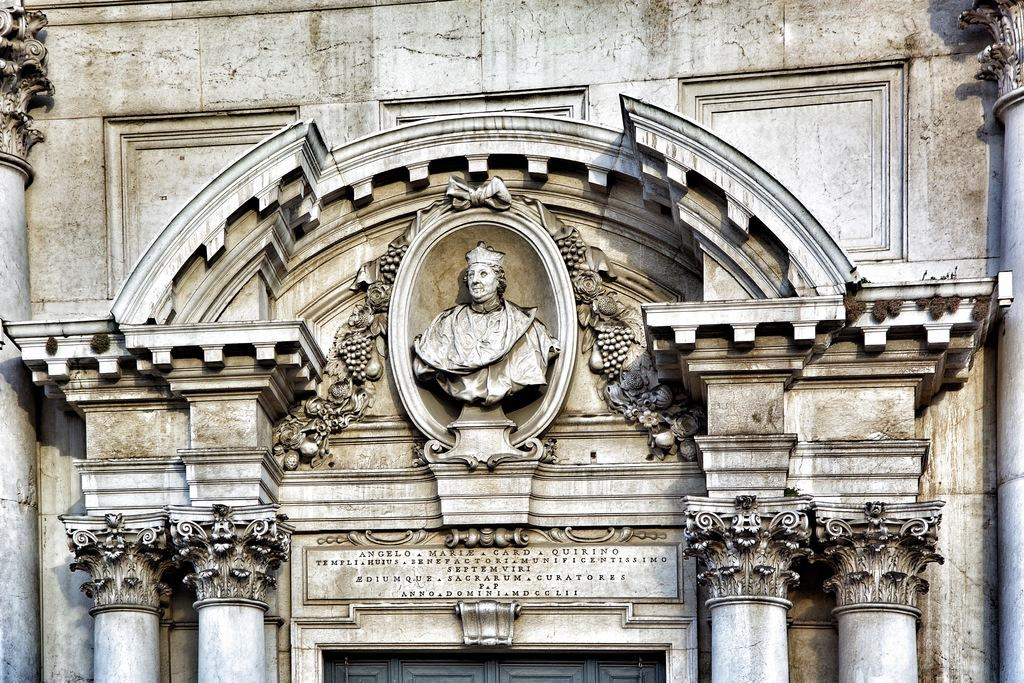What type of structure is visible in the image? There is a wall in the image. What can be seen in front of the wall? There are pillars in front of the wall. What is written on the wall? There is text written on the wall. What other object is present in the image? There is a statue in the image. What type of dirt can be seen on the band's instruments in the image? There is no band or instruments present in the image; it only features a wall, pillars, text, and a statue. 